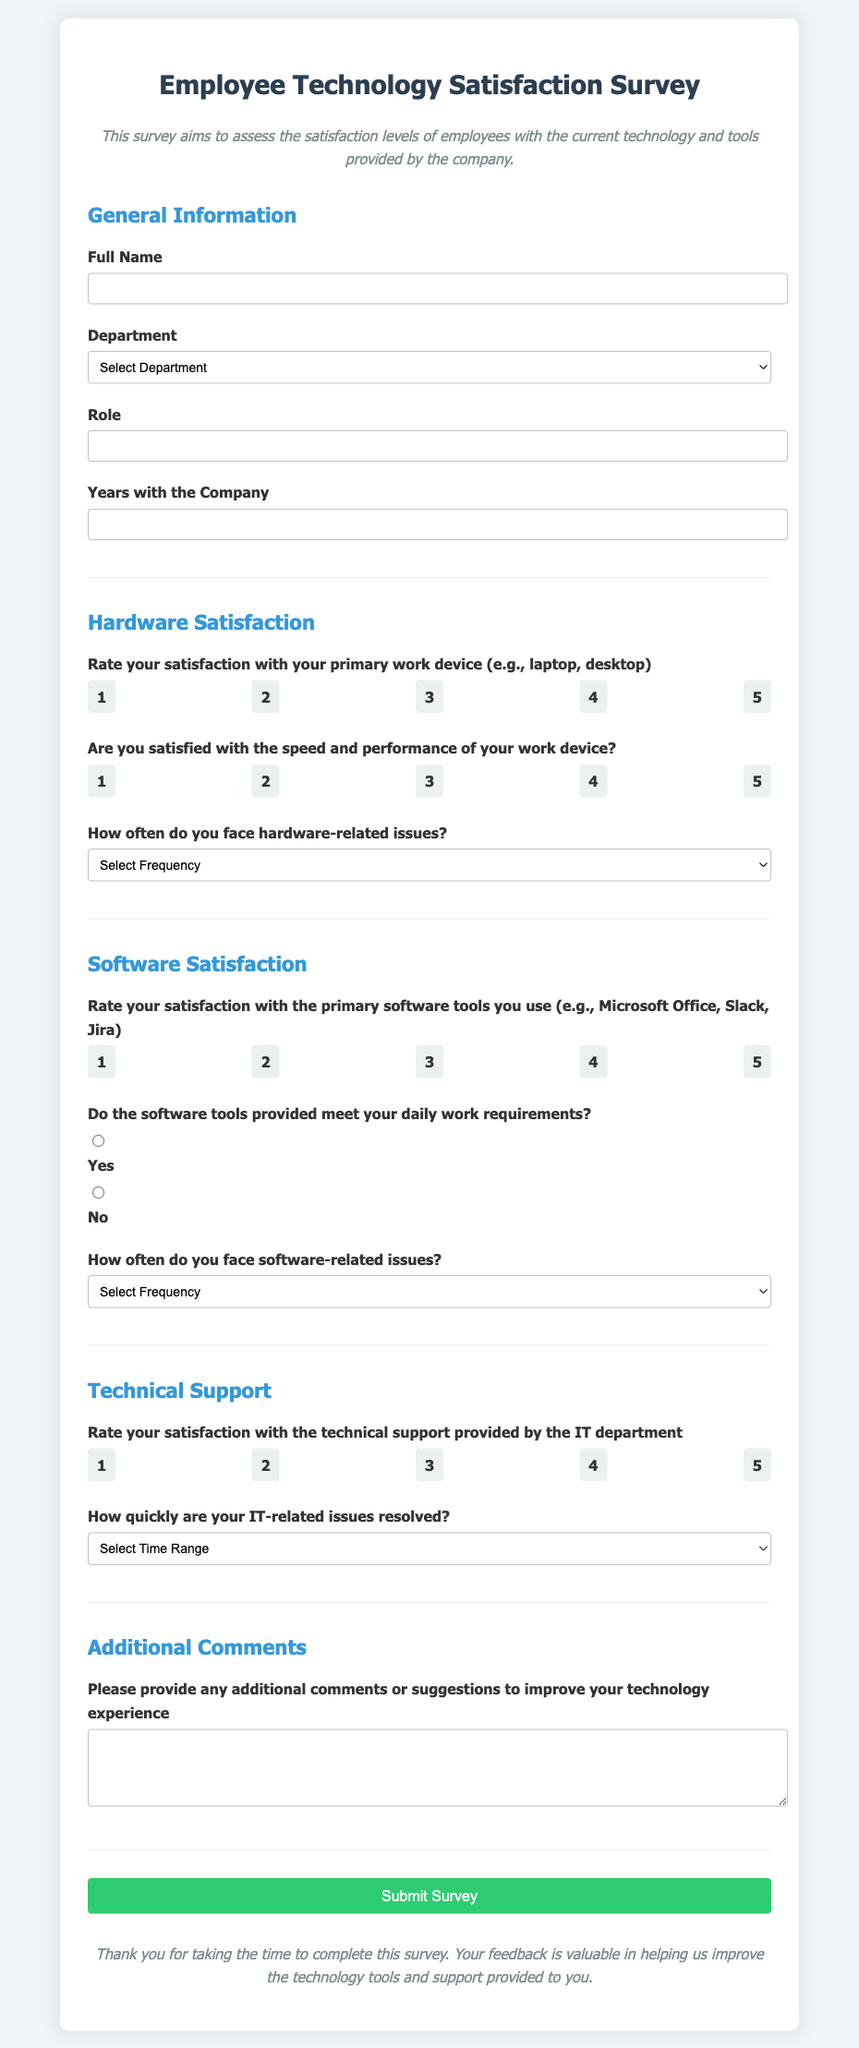What is the title of the survey? The title of the survey is provided in the header section of the document.
Answer: Employee Technology Satisfaction Survey What is the required input for the 'Full Name' field? The document specifies that the 'Full Name' field is a required input in the survey form.
Answer: Required How many departments are listed in the department selection? The document lists the departments that can be chosen in the department dropdown menu.
Answer: Six What is the maximum rating for satisfaction with primary work device? The document uses a rating system from 1 to 5 for various satisfaction questions.
Answer: 5 How often can you select as an option for hardware-related issues? The document provides options for how often the respondent faces hardware-related issues.
Answer: Five What is the range of responses for issue resolution time? The document lists options for the time taken to resolve IT-related issues, thus defining the range of responses.
Answer: Five Is there an option for 'Yes' or 'No' regarding software tools meeting requirements? The document presents an option to select if the software tools meet daily work requirements.
Answer: Yes and No What feedback section is included at the end of the survey? The document asks respondents for additional feedback in a specific section.
Answer: Additional Comments What is the button text to submit the survey? The document includes a submit button for the survey at the end.
Answer: Submit Survey 